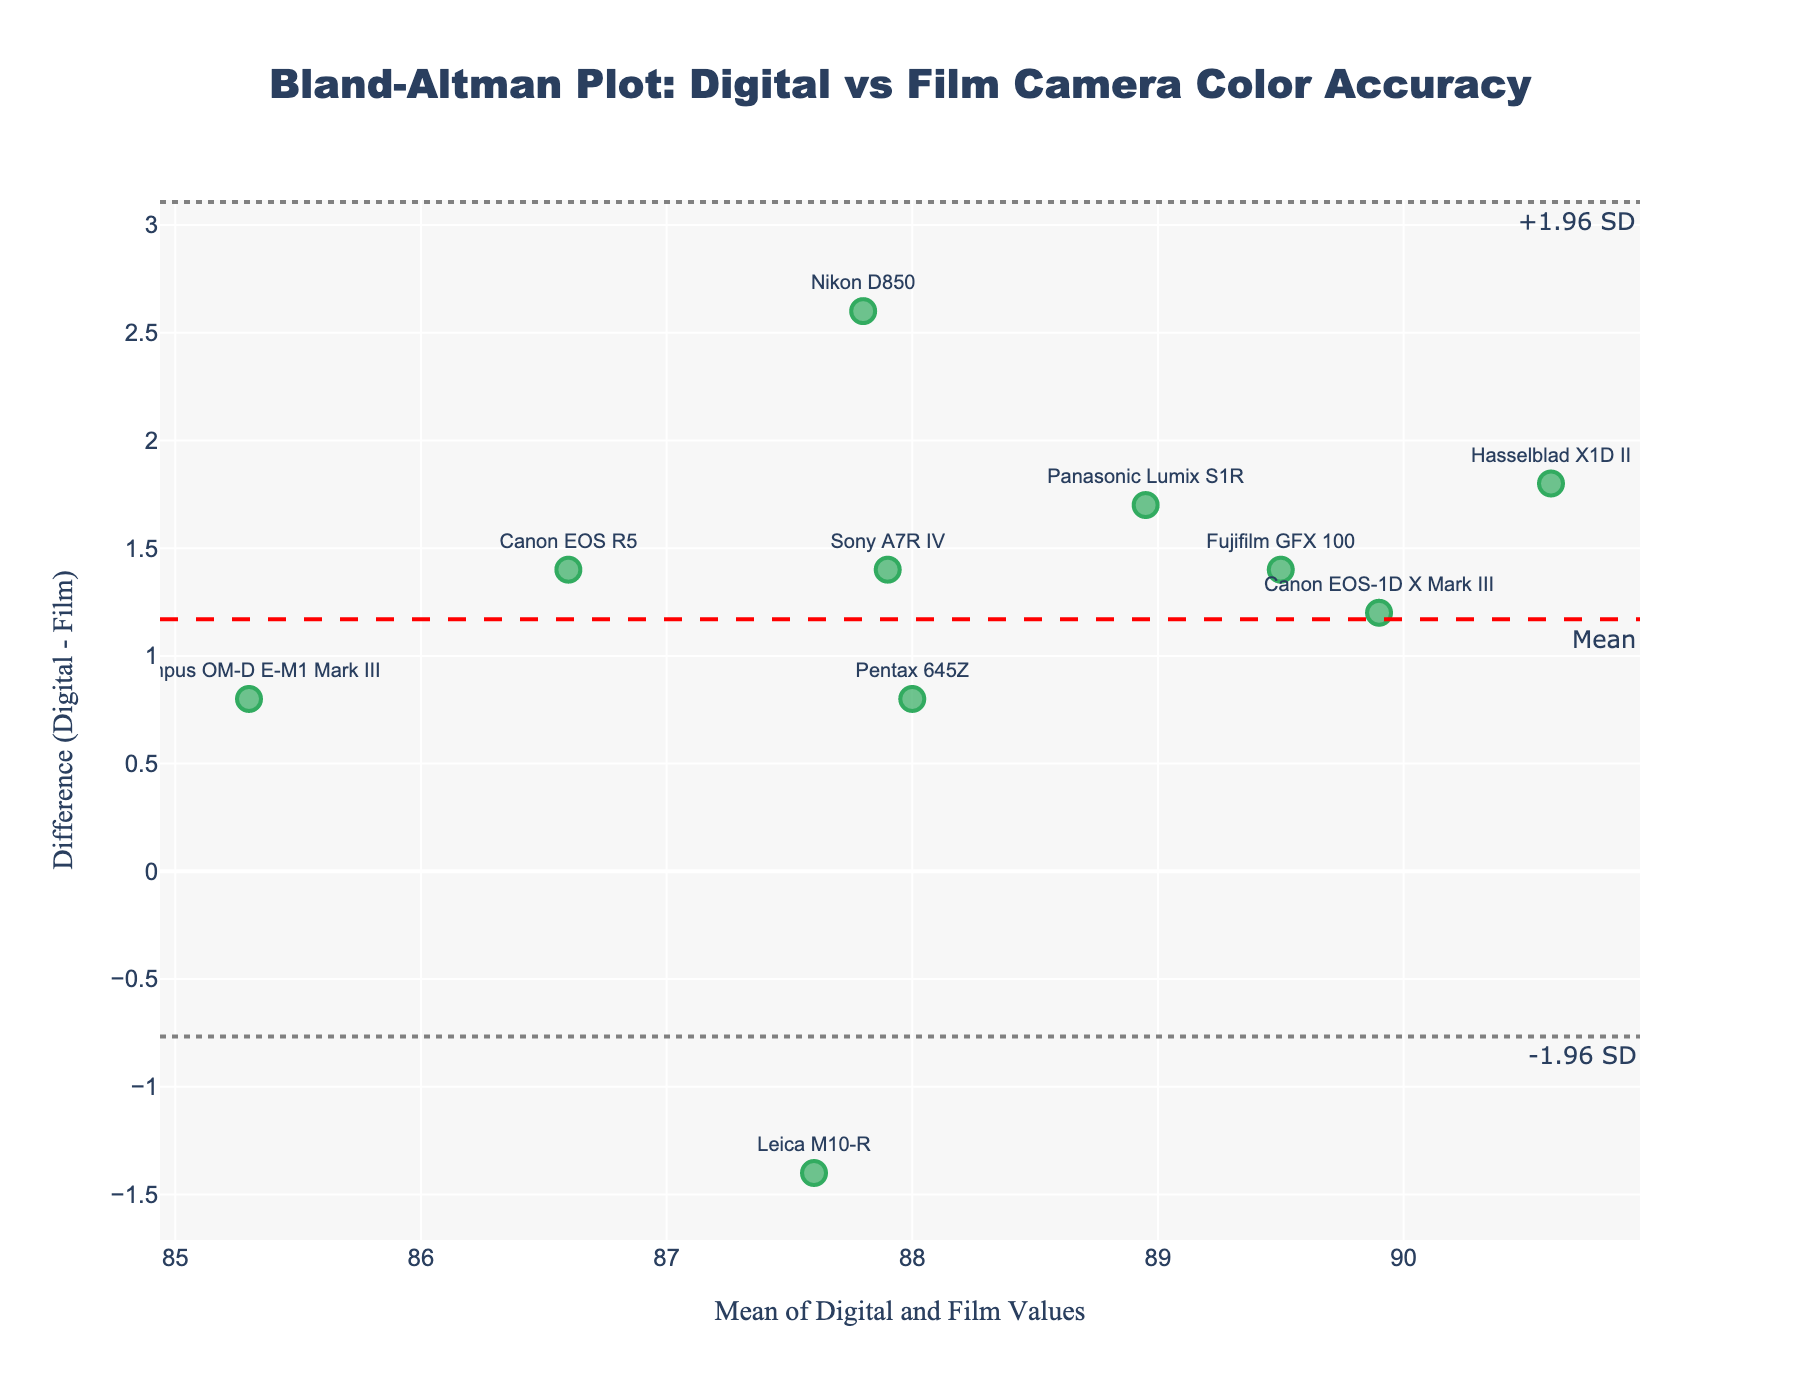What is the title of the plot? The title is displayed at the top of the plot. It reads "Bland-Altman Plot: Digital vs Film Camera Color Accuracy."
Answer: Bland-Altman Plot: Digital vs Film Camera Color Accuracy What do the x and y axes represent? The x-axis title is "Mean of Digital and Film Values," which represents the mean values of color accuracy for both digital and film cameras. The y-axis title is "Difference (Digital - Film)," which shows the difference in color accuracy between digital and film cameras.
Answer: x-axis: Mean of Digital and Film Values, y-axis: Difference (Digital - Film) How many cameras were analyzed in this plot? By counting the points (markers) labeled with the camera models, we can see there are 10 cameras listed.
Answer: 10 What is the mean difference between digital and film cameras’ color accuracy? The mean difference is indicated by the horizontal line labeled "Mean." This line is drawn at the y-coordinate of the mean difference.
Answer: ~1.65 Which camera shows the largest positive difference in color accuracy between digital and film? By looking at the y-values (differences) of each point, we see that the "Hasselblad X1D II" has the highest positive difference.
Answer: Hasselblad X1D II What are the upper and lower limits of agreement in the plot? The upper and lower limits of agreement are represented by the two dashed lines labeled "+1.96 SD" and "-1.96 SD," respectively. The upper limit is about 3.58, and the lower limit is about -0.28.
Answer: +1.96 SD: ~3.58, -1.96 SD: ~-0.28 What is the difference in color accuracy for the 'Leica M10-R' camera? The "Leica M10-R" marker is positioned at a y-value of about -1.4, representing its difference between digital and film values.
Answer: ~-1.4 Which camera has the closest agreement (smallest difference) between digital and film camera color accuracy? The "Olympus OM-D E-M1 Mark III" is closest to the x-axis (difference of 0), meaning it has the smallest difference.
Answer: Olympus OM-D E-M1 Mark III Is the majority of the data within the limits of agreement? By observing the placement of the points relative to the dashed horizontal lines representing the limits of agreement, we can see that most points fall between the upper and lower limits.
Answer: Yes What can you infer about the color accuracy of digital vs. film cameras from this plot? The plot shows that digital cameras generally have slightly higher color accuracy than film cameras, as indicated by the positive mean difference. The differences for most cameras fall within the limits of agreement, suggesting a reasonable level of consistency.
Answer: Digital cameras generally higher, consistent agreement 